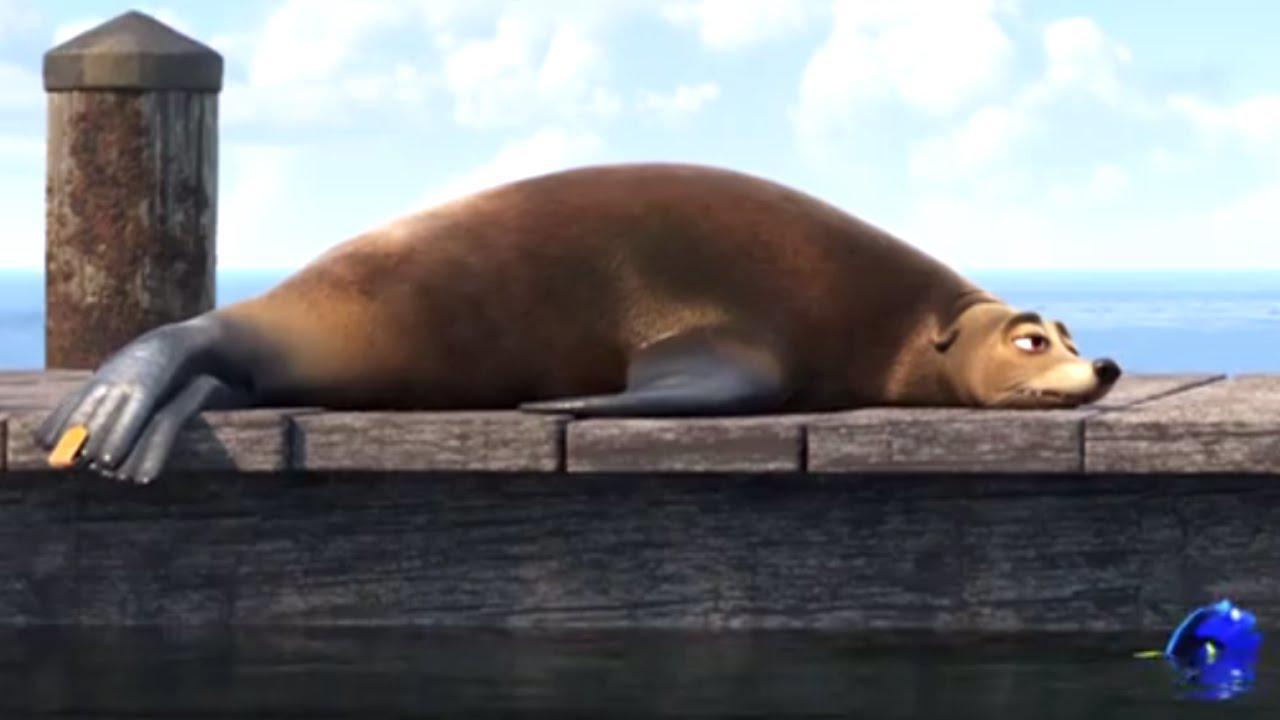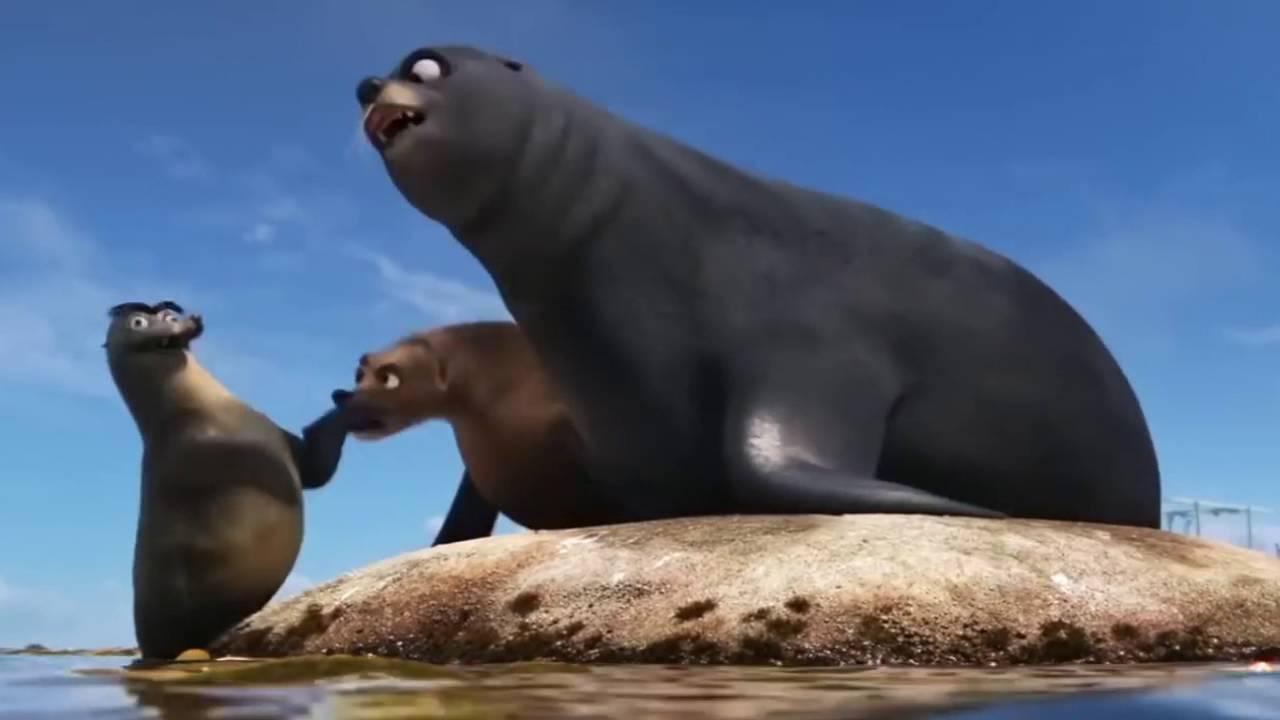The first image is the image on the left, the second image is the image on the right. For the images displayed, is the sentence "One image shoes three seals interacting with a small green bucket, and the other image shows two seals on a rock, one black and one brown." factually correct? Answer yes or no. No. The first image is the image on the left, the second image is the image on the right. For the images displayed, is the sentence "In one image, two seals are alone together on a small mound surrounded by water, and in the other image, a third seal has joined them on the mound." factually correct? Answer yes or no. No. 